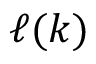<formula> <loc_0><loc_0><loc_500><loc_500>\ell ( k )</formula> 